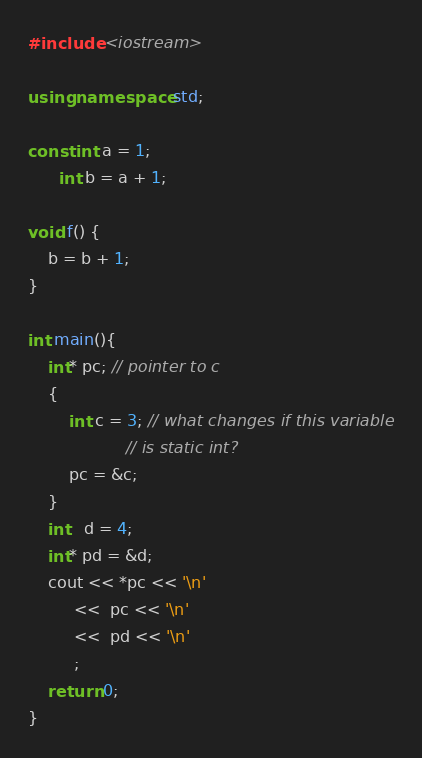<code> <loc_0><loc_0><loc_500><loc_500><_C++_>#include <iostream>

using namespace std;

const int a = 1;
      int b = a + 1;

void f() {
    b = b + 1;
}

int main(){
    int* pc; // pointer to c
    {
        int c = 3; // what changes if this variable
                   // is static int?
        pc = &c;
    }
    int   d = 4;
    int* pd = &d;
    cout << *pc << '\n'
         <<  pc << '\n'
         <<  pd << '\n'
         ;
    return 0;
}
</code> 